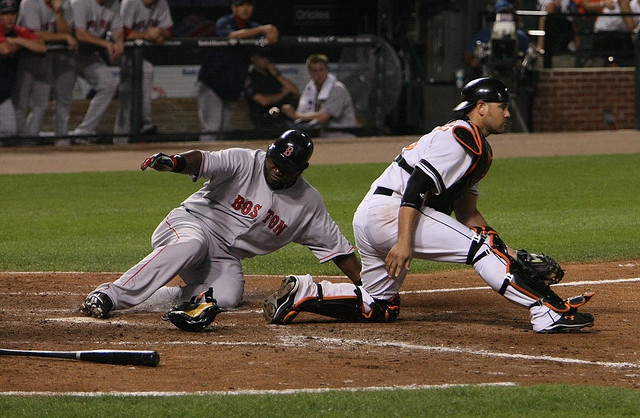Describe the objects in this image and their specific colors. I can see people in black, lavender, darkgray, and gray tones, people in black, darkgray, gray, and maroon tones, people in black, gray, and maroon tones, people in black, gray, and maroon tones, and people in black, gray, and maroon tones in this image. 